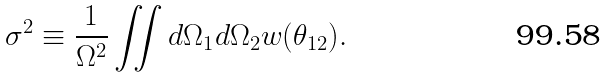<formula> <loc_0><loc_0><loc_500><loc_500>\sigma ^ { 2 } \equiv \frac { 1 } { \Omega ^ { 2 } } \iint d \Omega _ { 1 } d \Omega _ { 2 } w ( \theta _ { 1 2 } ) .</formula> 